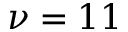<formula> <loc_0><loc_0><loc_500><loc_500>\nu = 1 1</formula> 